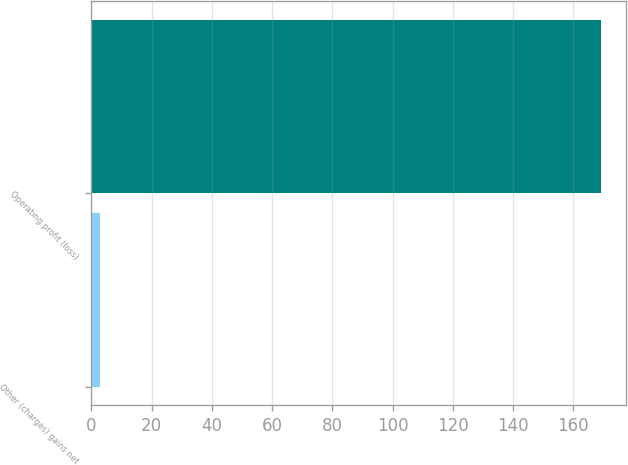Convert chart. <chart><loc_0><loc_0><loc_500><loc_500><bar_chart><fcel>Other (charges) gains net<fcel>Operating profit (loss)<nl><fcel>3<fcel>169<nl></chart> 